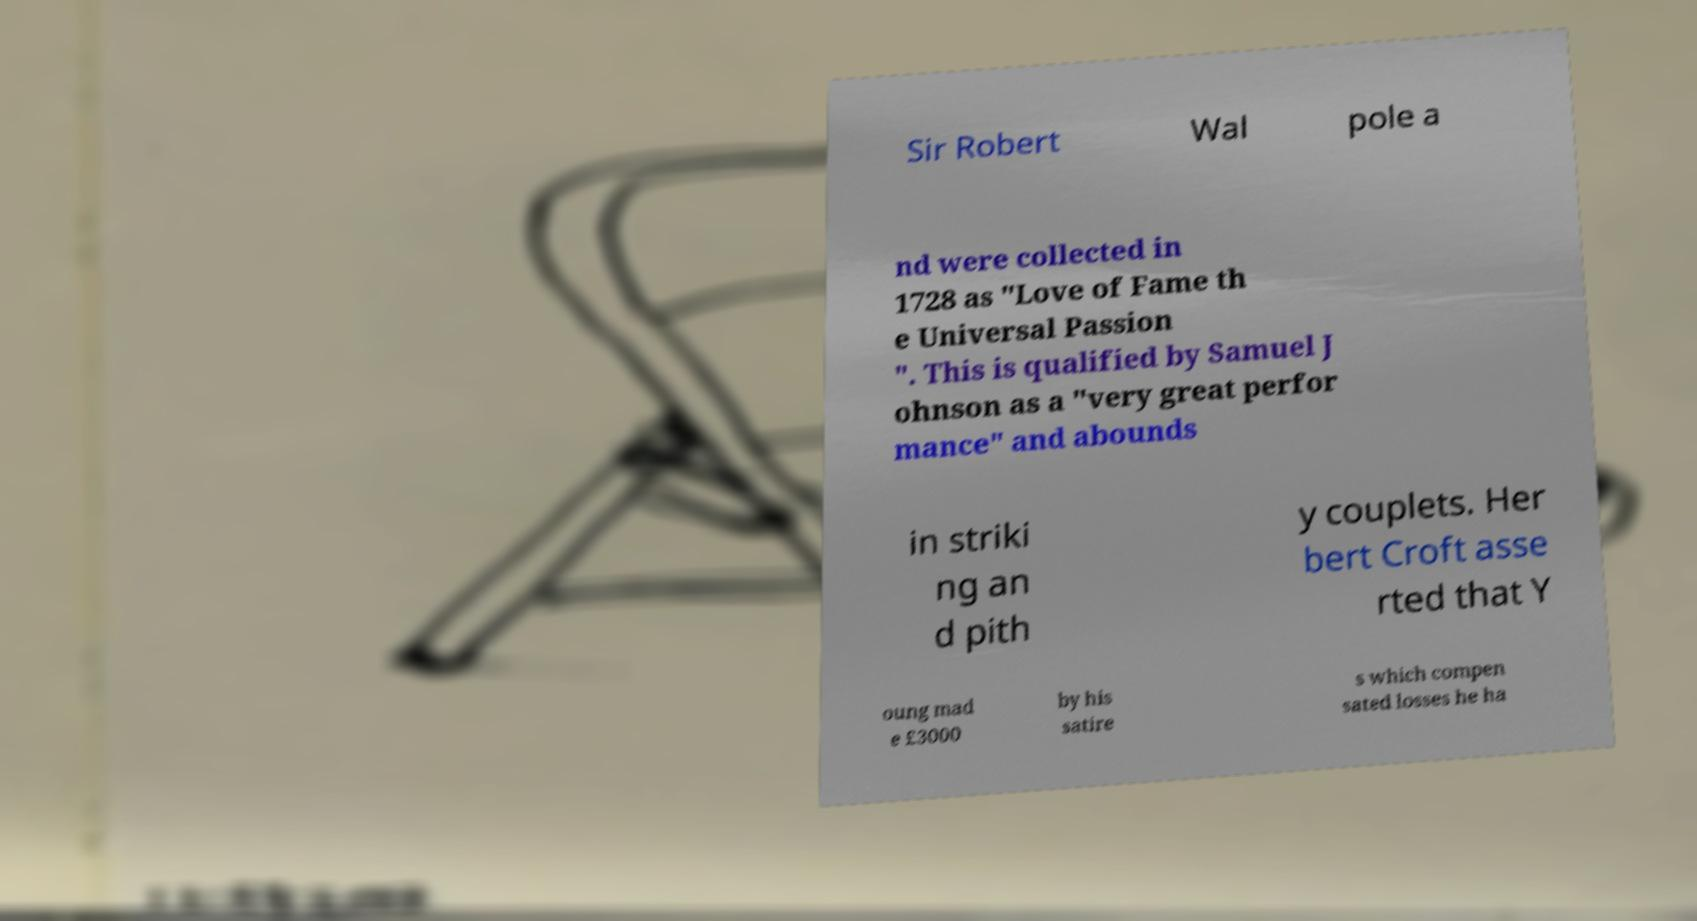What messages or text are displayed in this image? I need them in a readable, typed format. Sir Robert Wal pole a nd were collected in 1728 as "Love of Fame th e Universal Passion ". This is qualified by Samuel J ohnson as a "very great perfor mance" and abounds in striki ng an d pith y couplets. Her bert Croft asse rted that Y oung mad e £3000 by his satire s which compen sated losses he ha 